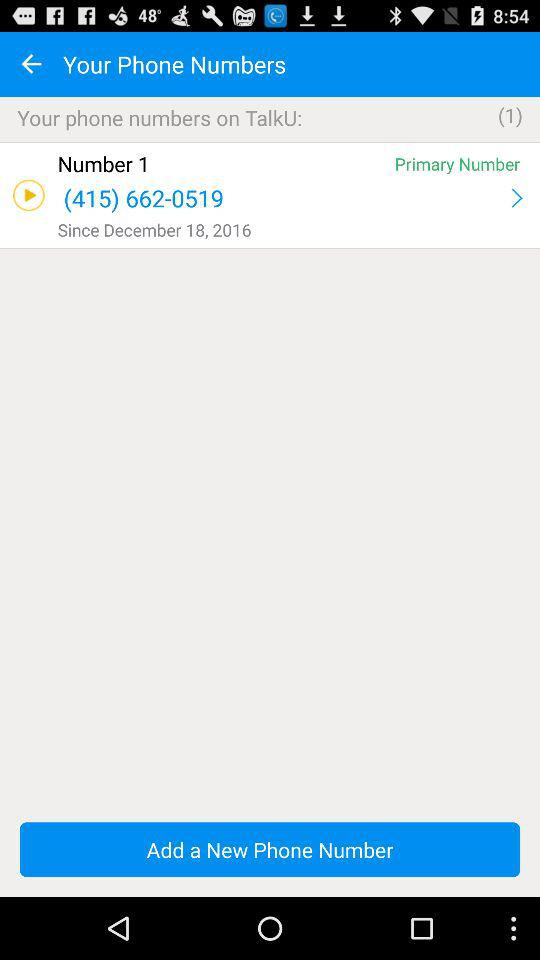When was the contact of "number 1" saved on the phone? The contact was saved on December 18, 2016. 